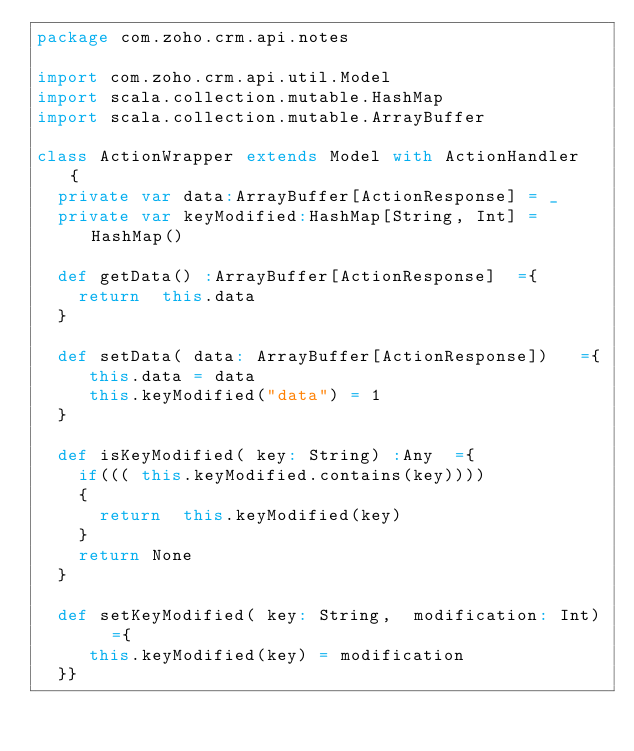<code> <loc_0><loc_0><loc_500><loc_500><_Scala_>package com.zoho.crm.api.notes

import com.zoho.crm.api.util.Model
import scala.collection.mutable.HashMap
import scala.collection.mutable.ArrayBuffer

class ActionWrapper extends Model with ActionHandler	{
	private var data:ArrayBuffer[ActionResponse] = _
	private var keyModified:HashMap[String, Int] = HashMap()

	def getData() :ArrayBuffer[ActionResponse]	={
		return  this.data
	}

	def setData( data: ArrayBuffer[ActionResponse]) 	={
		 this.data = data
		 this.keyModified("data") = 1
	}

	def isKeyModified( key: String) :Any	={
		if((( this.keyModified.contains(key))))
		{
			return  this.keyModified(key)
		}
		return None
	}

	def setKeyModified( key: String,  modification: Int) 	={
		 this.keyModified(key) = modification
	}}</code> 